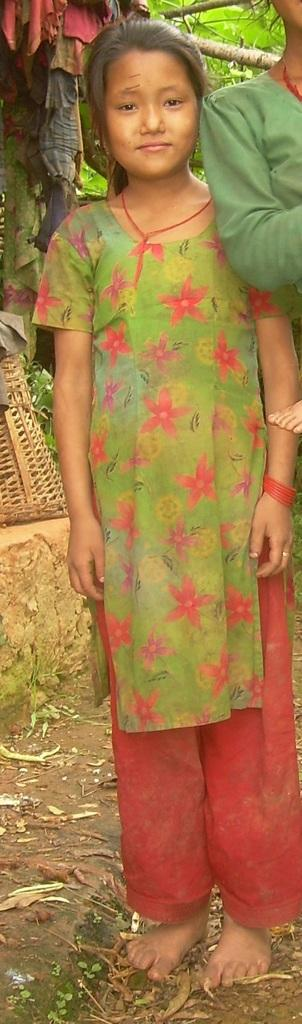How many people are visible in the image? There are two people standing in the front of the image. What can be seen in the background of the image? There is a basket and a tree in the background of the image. What type of kitty is sitting on the finger of one of the people in the image? There is no kitty present in the image. How does the friction between the two people affect the image? The concept of friction is not applicable to the image, as it involves the interaction between two surfaces in contact, and there are no such interactions depicted in the image. 